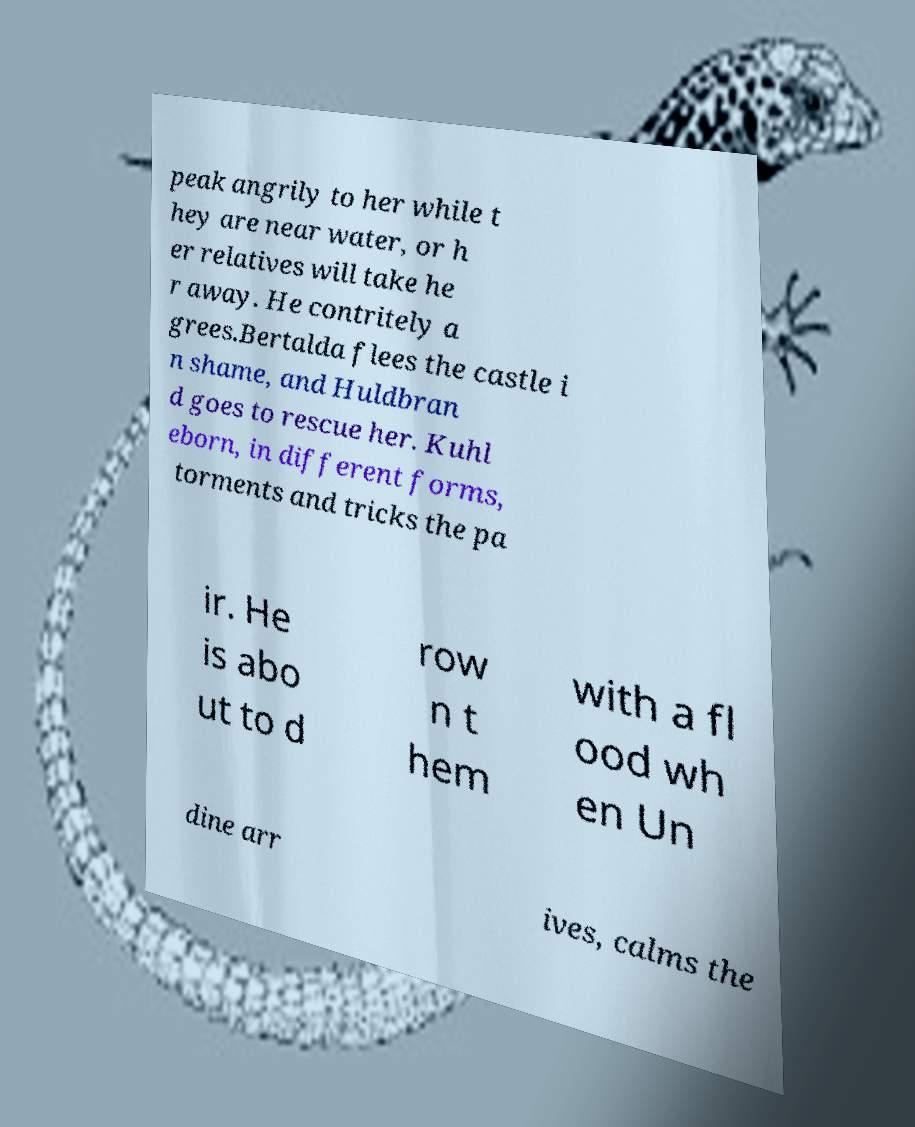I need the written content from this picture converted into text. Can you do that? peak angrily to her while t hey are near water, or h er relatives will take he r away. He contritely a grees.Bertalda flees the castle i n shame, and Huldbran d goes to rescue her. Kuhl eborn, in different forms, torments and tricks the pa ir. He is abo ut to d row n t hem with a fl ood wh en Un dine arr ives, calms the 